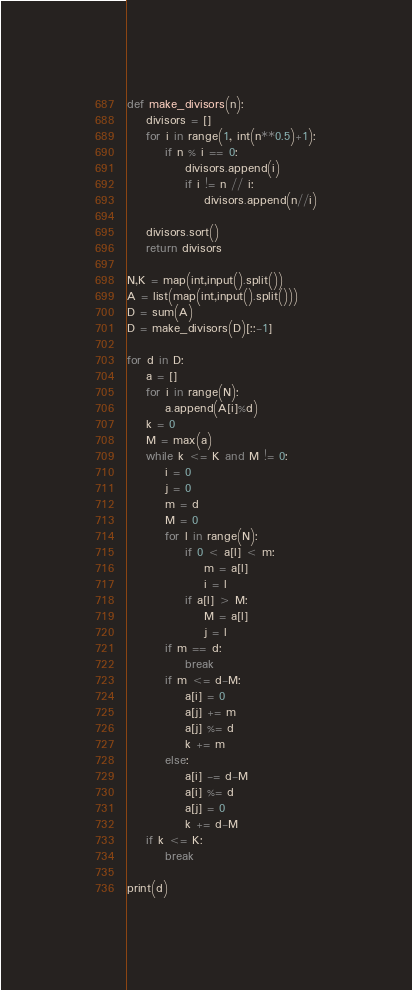<code> <loc_0><loc_0><loc_500><loc_500><_Python_>def make_divisors(n):
    divisors = []
    for i in range(1, int(n**0.5)+1):
        if n % i == 0:
            divisors.append(i)
            if i != n // i:
                divisors.append(n//i)

    divisors.sort()
    return divisors

N,K = map(int,input().split())
A = list(map(int,input().split()))
D = sum(A)
D = make_divisors(D)[::-1]

for d in D:
    a = []
    for i in range(N):
        a.append(A[i]%d)
    k = 0
    M = max(a)
    while k <= K and M != 0:
        i = 0
        j = 0
        m = d
        M = 0
        for l in range(N):
            if 0 < a[l] < m:
                m = a[l]
                i = l
            if a[l] > M:
                M = a[l]
                j = l
        if m == d:
            break
        if m <= d-M:
            a[i] = 0
            a[j] += m
            a[j] %= d
            k += m
        else:
            a[i] -= d-M
            a[i] %= d
            a[j] = 0
            k += d-M
    if k <= K:
        break

print(d)</code> 